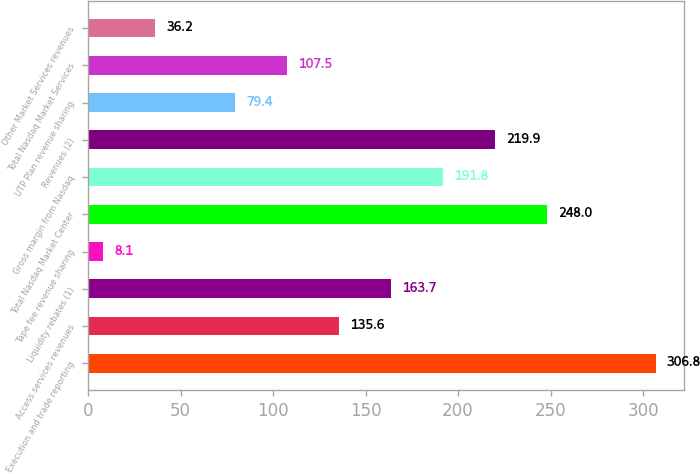Convert chart. <chart><loc_0><loc_0><loc_500><loc_500><bar_chart><fcel>Execution and trade reporting<fcel>Access services revenues<fcel>Liquidity rebates (1)<fcel>Tape fee revenue sharing<fcel>Total Nasdaq Market Center<fcel>Gross margin from Nasdaq<fcel>Revenues (2)<fcel>UTP Plan revenue sharing<fcel>Total Nasdaq Market Services<fcel>Other Market Services revenues<nl><fcel>306.8<fcel>135.6<fcel>163.7<fcel>8.1<fcel>248<fcel>191.8<fcel>219.9<fcel>79.4<fcel>107.5<fcel>36.2<nl></chart> 